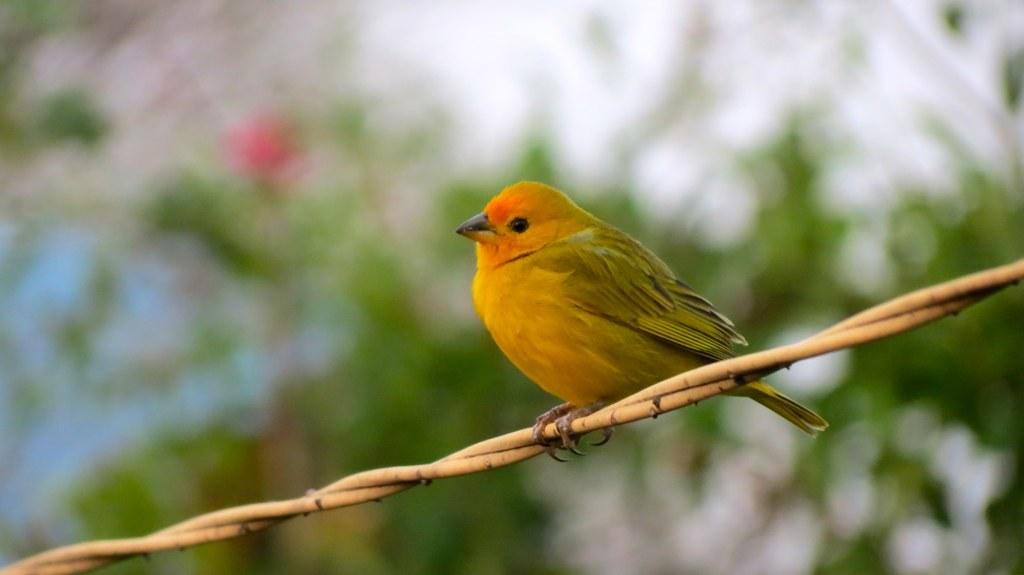What type of animal is in the image? There is a yellow bird in the image. What is the bird standing on? The bird is standing on a cable. Can you describe the background of the image? The background of the image is blurry. What invention is being demonstrated by the bird in the image? There is no invention being demonstrated by the bird in the image; it is simply standing on a cable. 